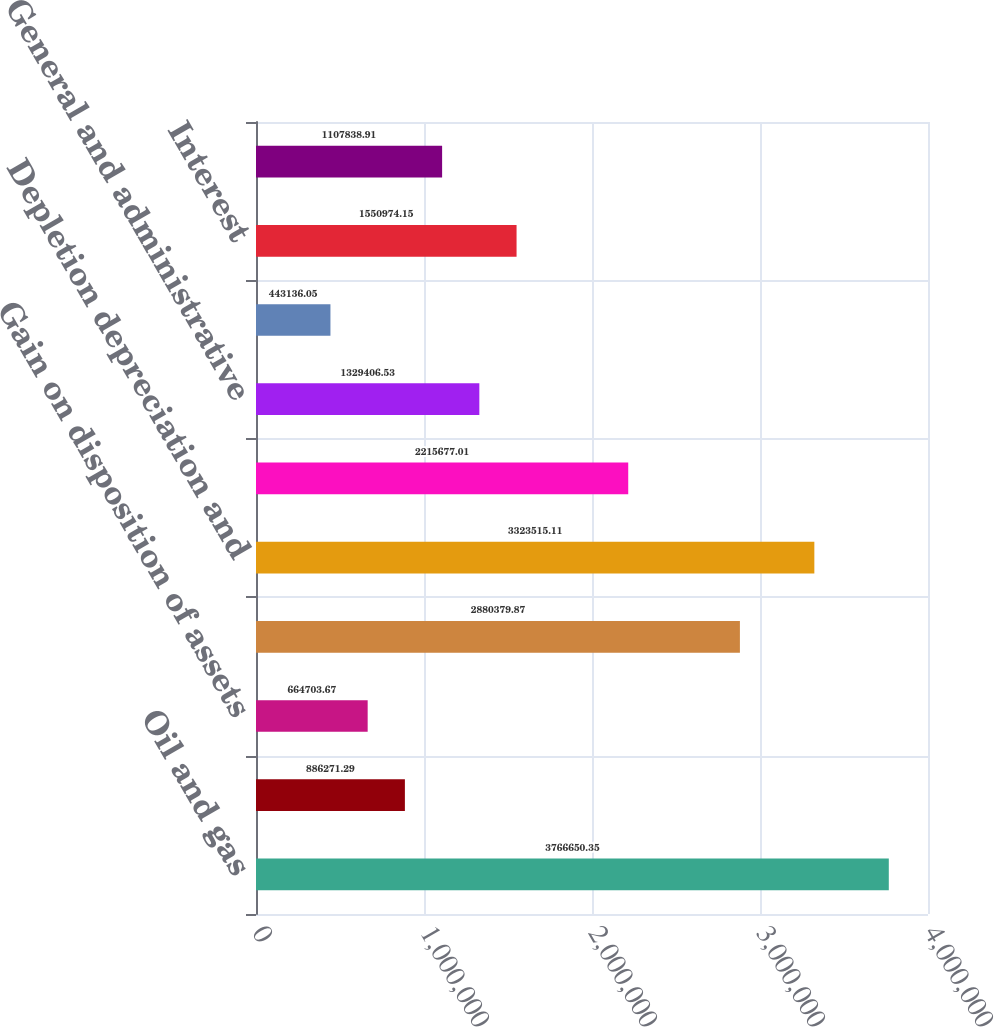Convert chart. <chart><loc_0><loc_0><loc_500><loc_500><bar_chart><fcel>Oil and gas<fcel>Interest and other<fcel>Gain on disposition of assets<fcel>Oil and gas production<fcel>Depletion depreciation and<fcel>Exploration and abandonments<fcel>General and administrative<fcel>Accretion of discount on asset<fcel>Interest<fcel>Other<nl><fcel>3.76665e+06<fcel>886271<fcel>664704<fcel>2.88038e+06<fcel>3.32352e+06<fcel>2.21568e+06<fcel>1.32941e+06<fcel>443136<fcel>1.55097e+06<fcel>1.10784e+06<nl></chart> 